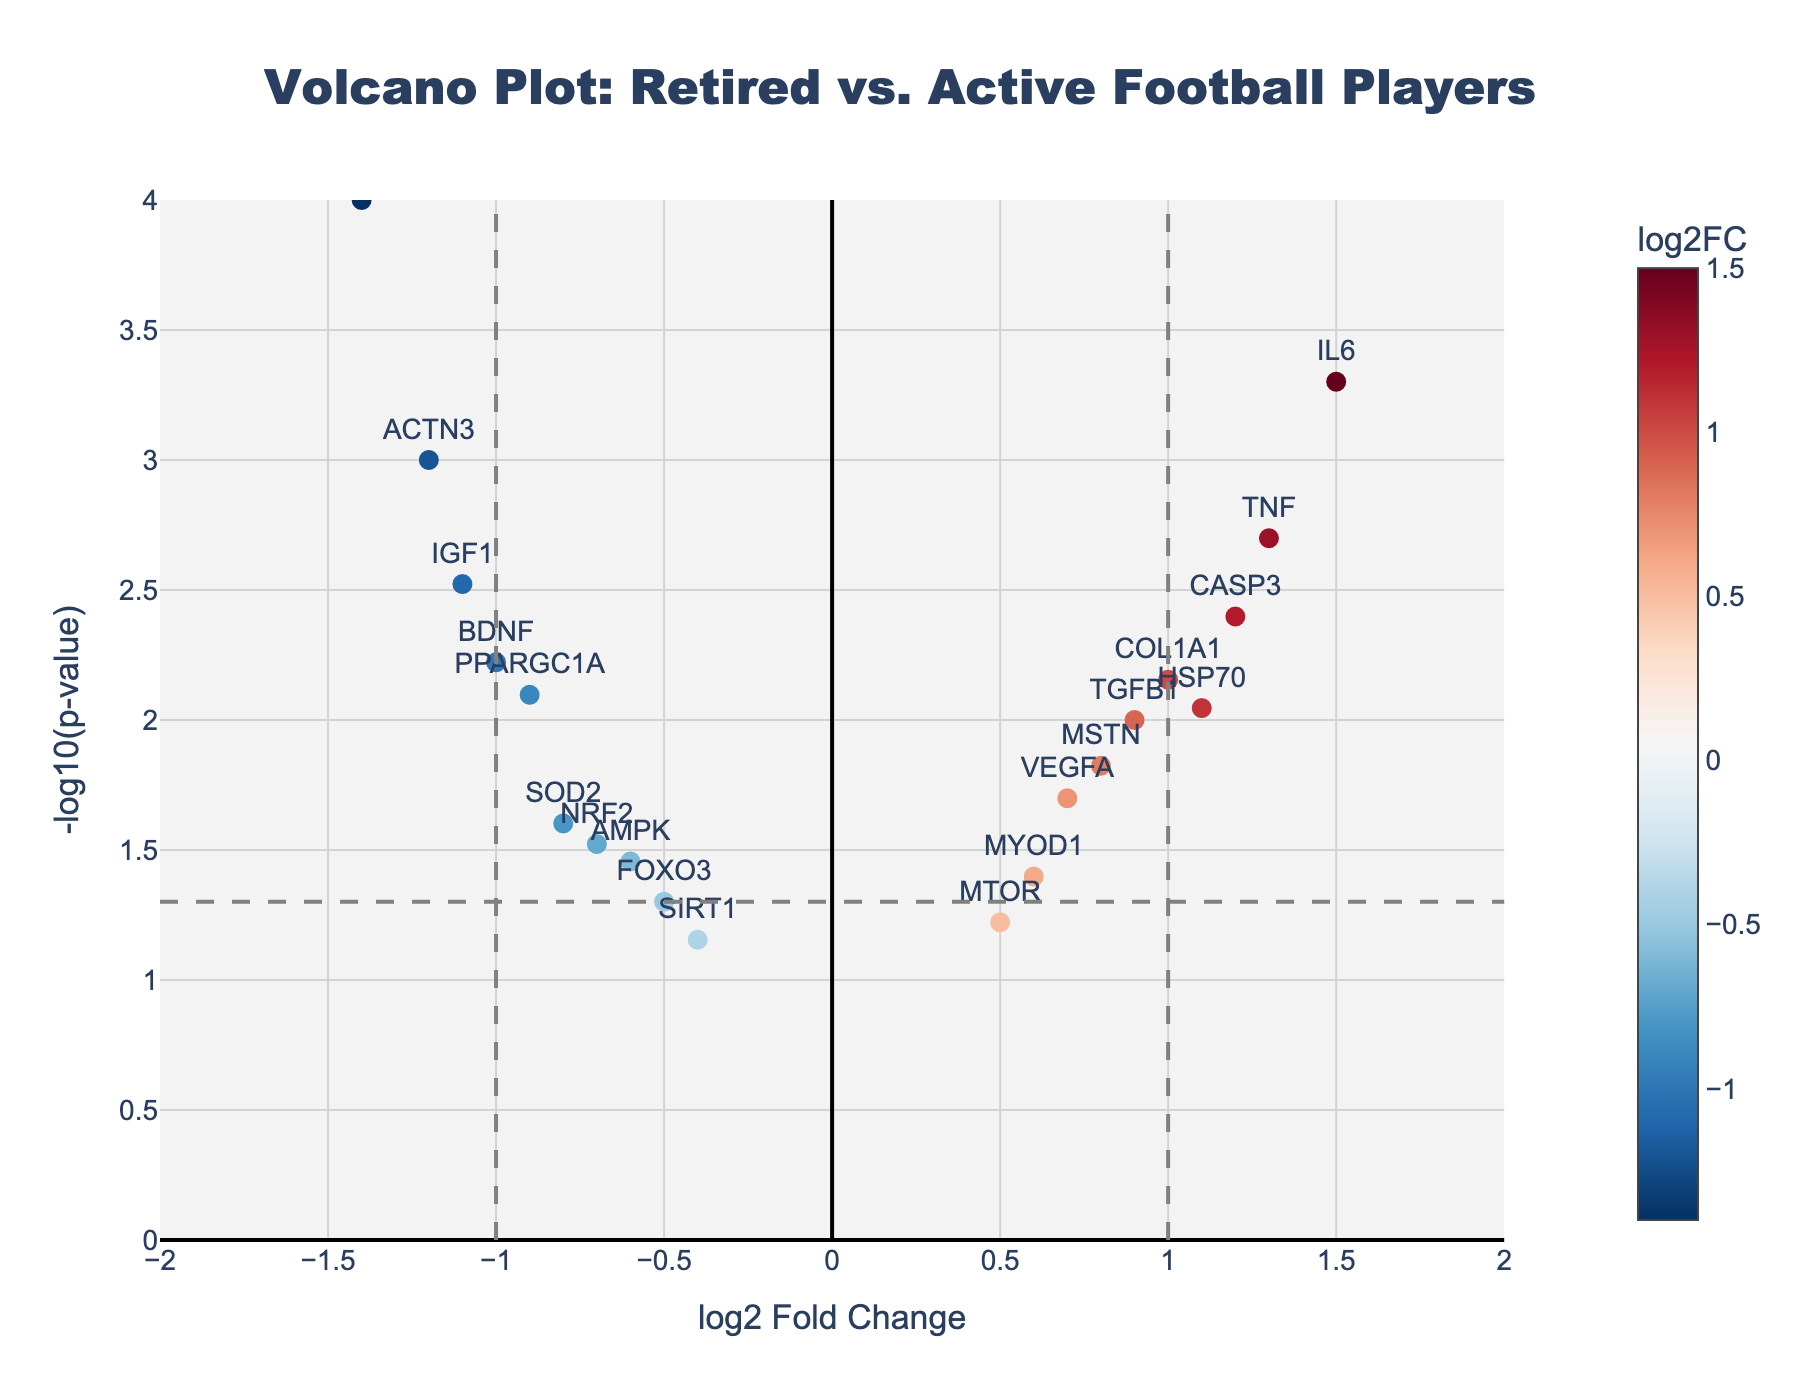What is the title of the plot? The title of the plot is located at the top of the figure, usually in a larger and bold font. It helps in identifying the context of the plot.
Answer: Volcano Plot: Retired vs. Active Football Players What does the x-axis represent? The x-axis represents the log2 fold change, which indicates the ratio of expression levels of genes between two conditions (retired vs. active football players).
Answer: log2 Fold Change How many genes have a significant p-value (less than 0.05)? The dashed horizontal line on the y-axis represents the threshold for significance (-log10(p-value) = 1.3 for p-value = 0.05). Any data points above this line have a significant p-value.
Answer: 16 Which gene has the highest -log10(p-value)? The highest -log10(p-value) corresponds to the data point with the greatest y-axis value. By visually inspecting, MYH7 is the highest on the y-axis.
Answer: MYH7 How many genes have a positive log2 fold change and a significant p-value? Positive log2 fold change means genes on the right side of the x-axis, and significant p-value means they are above the horizontal dashed line. Count the number of these points.
Answer: 9 Which gene has the largest absolute log2 fold change? The absolute log2 fold change is the farthest distance from zero on the x-axis. The gene MYH7 is farthest to the left, indicating the largest negative value.
Answer: MYH7 Which genes have a log2 fold change greater than 1 and a p-value less than 0.01? Locate genes to the right of the x-axis at log2 fold change > 1 and above the horizontal line at y > 2. These genes are IL6 and TNF.
Answer: IL6 and TNF What is the log2 fold change and p-value for the gene VEGFA? Hovering over the data point labeled VEGFA gives the hovertext showing the log2FC and p-value information.
Answer: 0.7 and 0.02 How is the colorbar helpful in the scatter plot? The colorbar represents the log2FC values with different colors indicating whether the gene is upregulated (positive fold change) or downregulated (negative fold change). This helps in visual differentiation of upregulated and downregulated genes.
Answer: Indicates fold change direction Compare the expressions of IGF1 and CASP3. Which one is more downregulated and has a more significant p-value? Look at the positions of IGF1 and CASP3. IGF1 has a more negative log2 fold change value (more downregulated) and is slightly higher on the y-axis (more significant p-value).
Answer: IGF1 